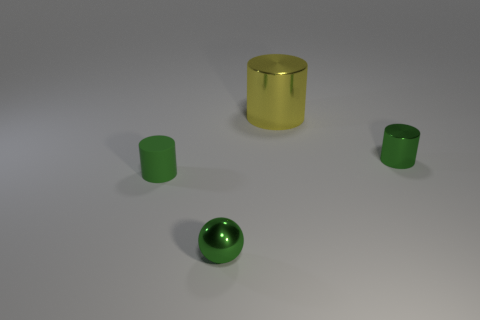Add 1 big purple cylinders. How many objects exist? 5 Subtract all cylinders. How many objects are left? 1 Add 1 large brown shiny objects. How many large brown shiny objects exist? 1 Subtract 1 green cylinders. How many objects are left? 3 Subtract all brown rubber objects. Subtract all tiny cylinders. How many objects are left? 2 Add 1 yellow metal cylinders. How many yellow metal cylinders are left? 2 